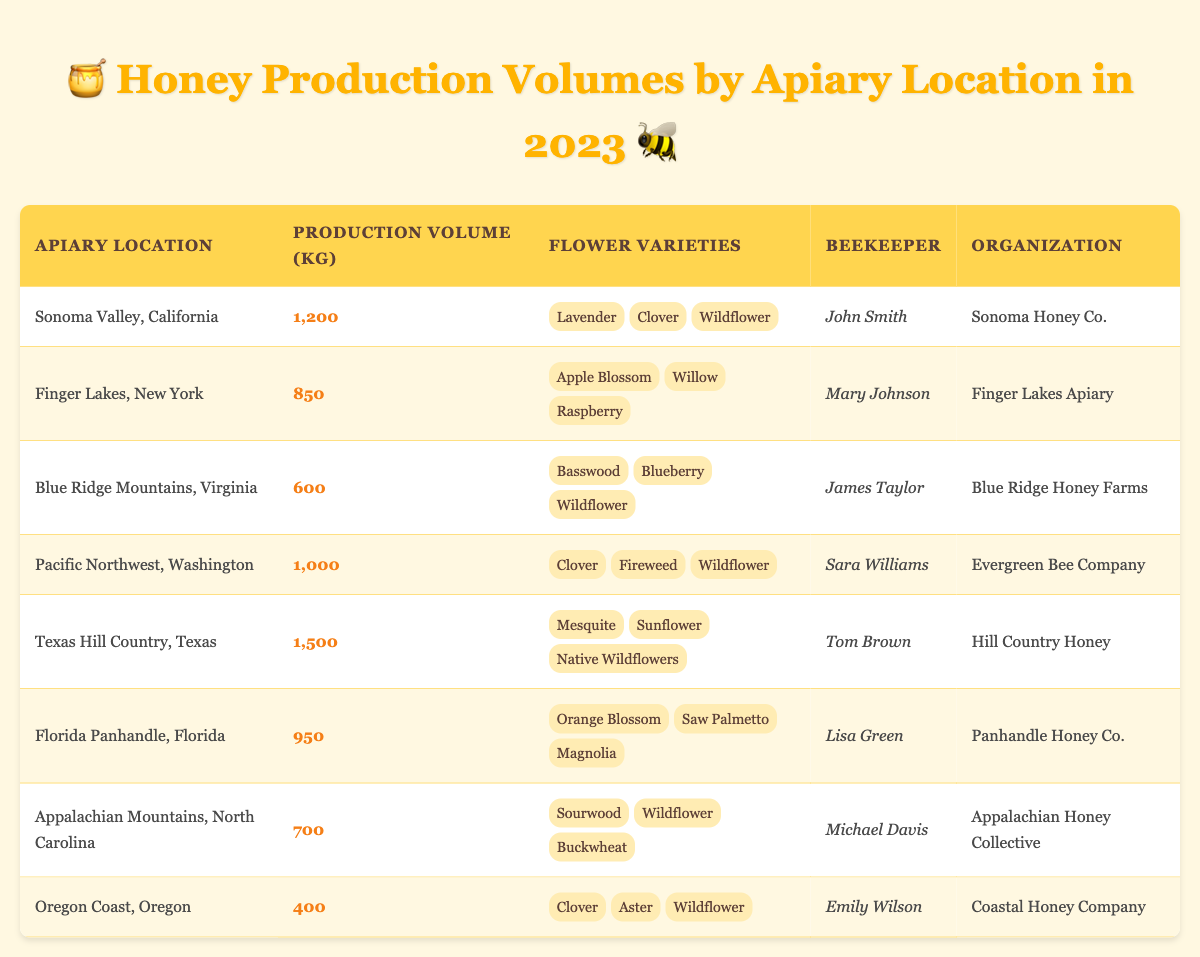What is the production volume of honey in Texas Hill Country, Texas? The production volume is listed in the table under the "Production Volume (kg)" column for the Texas Hill Country entry. It states "1,500".
Answer: 1500 Which apiary location has the highest honey production volume? By inspecting the "Production Volume (kg)" column, Texas Hill Country has the highest number, "1,500", compared to the other entries.
Answer: Texas Hill Country, Texas What flower variety is common among the honey produced in Sonoma Valley, California? Flower varieties are listed in the corresponding row for Sonoma Valley. The common flower varieties listed are Lavender, Clover, and Wildflower.
Answer: Lavender, Clover, Wildflower Is there honey production in the Oregon Coast, Oregon? The table shows a row for the Oregon Coast, which indicates a production volume of "400", confirming honey production is present there.
Answer: Yes What is the total honey production volume for the Finger Lakes, New York, and the Blue Ridge Mountains, Virginia? The production volumes for Finger Lakes (850 kg) and Blue Ridge Mountains (600 kg) need to be summed together. Therefore, 850 + 600 = 1450 kg.
Answer: 1450 How many different flower varieties are listed for honey production in the Pacific Northwest, Washington? The row for Pacific Northwest lists three distinct flower varieties: Clover, Fireweed, and Wildflower. Counting them gives a total of three.
Answer: 3 Is the beekeeper in the Florida Panhandle, Florida, named Lisa Green? The table states that the beekeeper for Florida Panhandle is indeed listed as Lisa Green, which confirms the statement is true.
Answer: Yes Which apiary location has the lowest production volume? Reviewing the "Production Volume (kg)" column, it shows that Oregon Coast has the lowest production volume of "400" kg when compared to other locations.
Answer: Oregon Coast, Oregon What is the average honey production volume across all apiary locations? To find the average, sum all production volumes: 1200 + 850 + 600 + 1000 + 1500 + 950 + 700 + 400 = 5150 kg. Then, divide this total by the number of locations (8): 5150 / 8 = 643.75 kg.
Answer: 643.75 